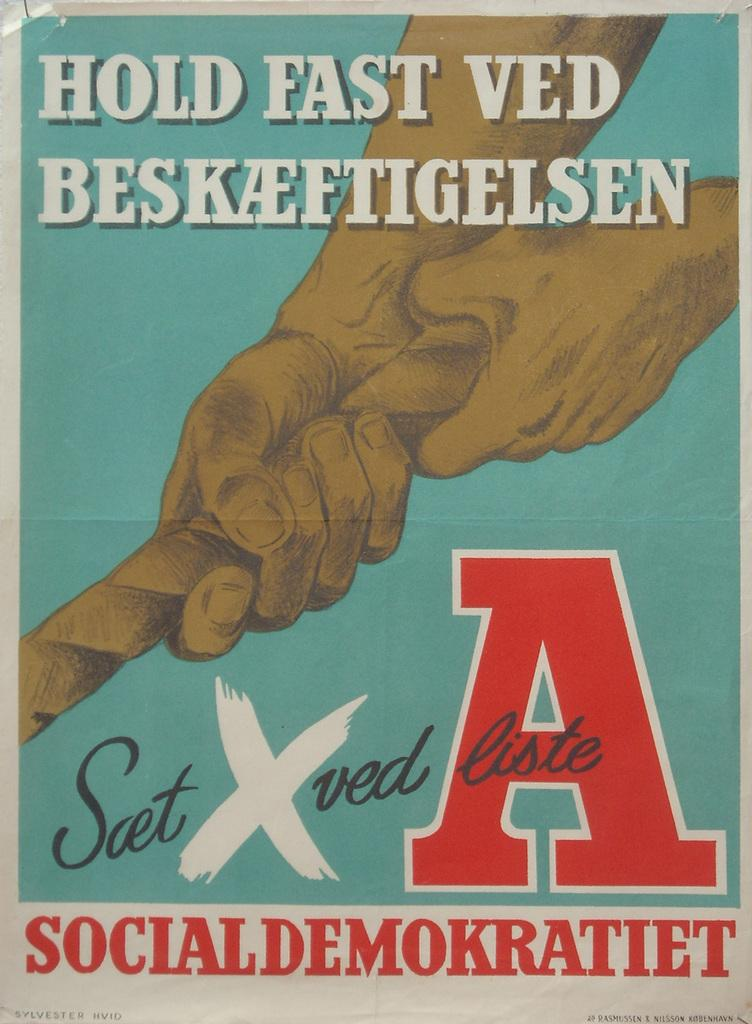<image>
Share a concise interpretation of the image provided. a poster saying "Hold Fast Ved" with hands pulling a rope 